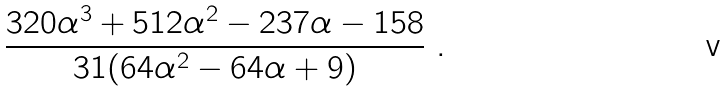Convert formula to latex. <formula><loc_0><loc_0><loc_500><loc_500>\frac { 3 2 0 \alpha ^ { 3 } + 5 1 2 \alpha ^ { 2 } - 2 3 7 \alpha - 1 5 8 } { 3 1 ( 6 4 \alpha ^ { 2 } - 6 4 \alpha + 9 ) } \ .</formula> 